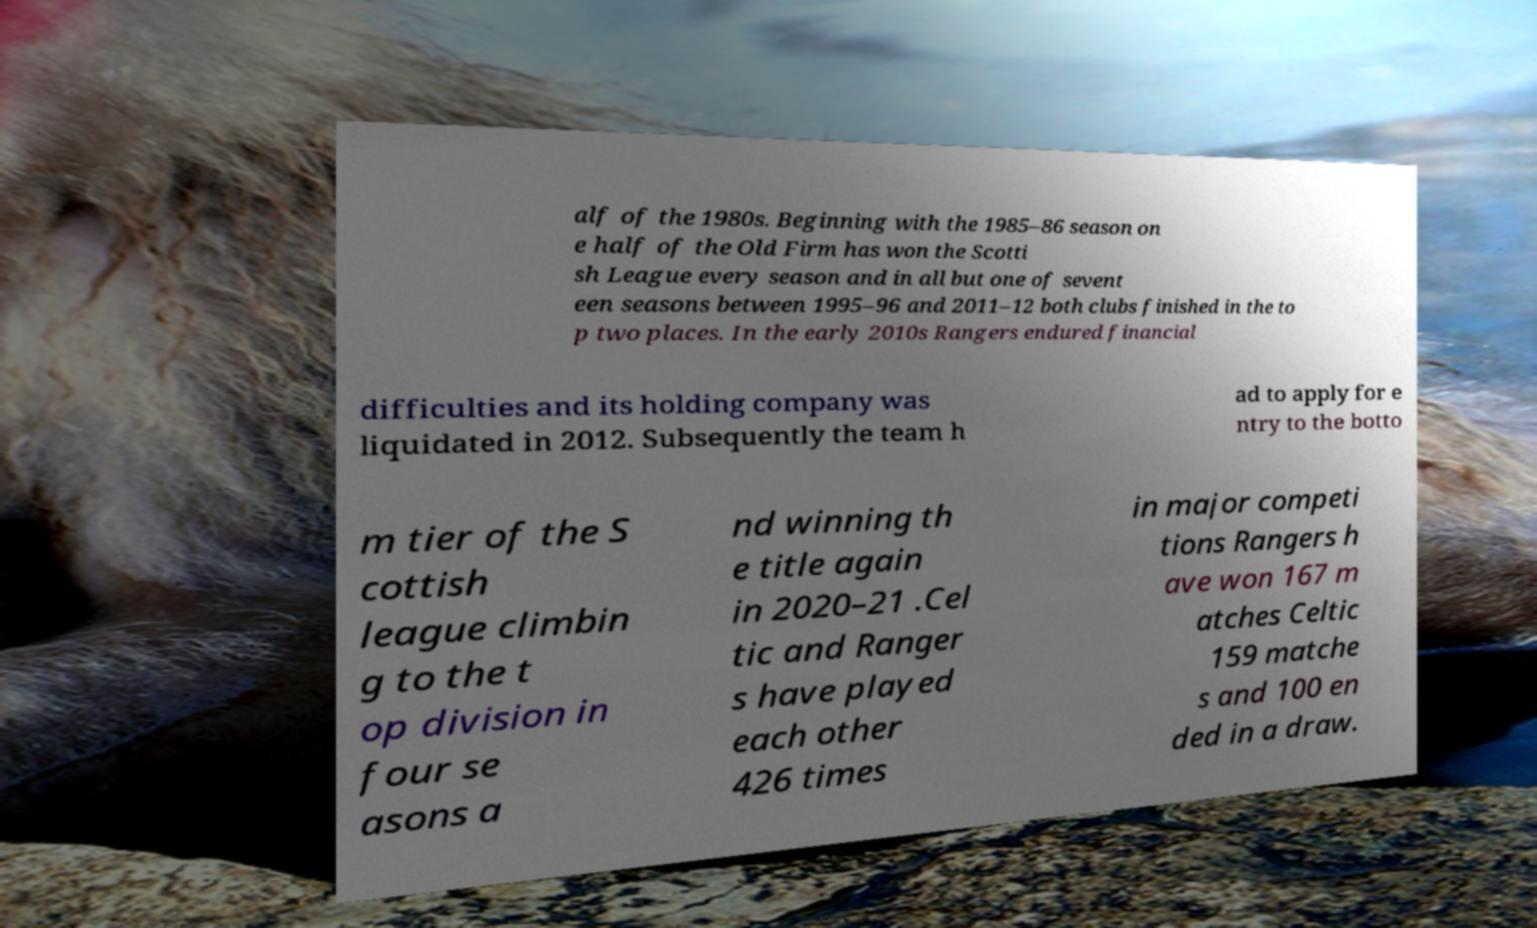Please read and relay the text visible in this image. What does it say? alf of the 1980s. Beginning with the 1985–86 season on e half of the Old Firm has won the Scotti sh League every season and in all but one of sevent een seasons between 1995–96 and 2011–12 both clubs finished in the to p two places. In the early 2010s Rangers endured financial difficulties and its holding company was liquidated in 2012. Subsequently the team h ad to apply for e ntry to the botto m tier of the S cottish league climbin g to the t op division in four se asons a nd winning th e title again in 2020–21 .Cel tic and Ranger s have played each other 426 times in major competi tions Rangers h ave won 167 m atches Celtic 159 matche s and 100 en ded in a draw. 